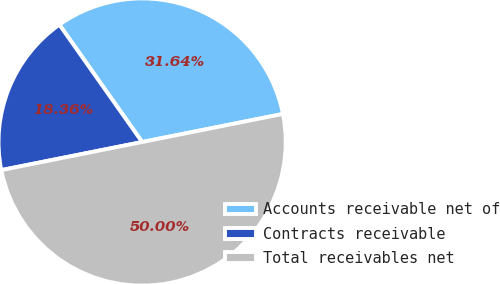Convert chart to OTSL. <chart><loc_0><loc_0><loc_500><loc_500><pie_chart><fcel>Accounts receivable net of<fcel>Contracts receivable<fcel>Total receivables net<nl><fcel>31.64%<fcel>18.36%<fcel>50.0%<nl></chart> 